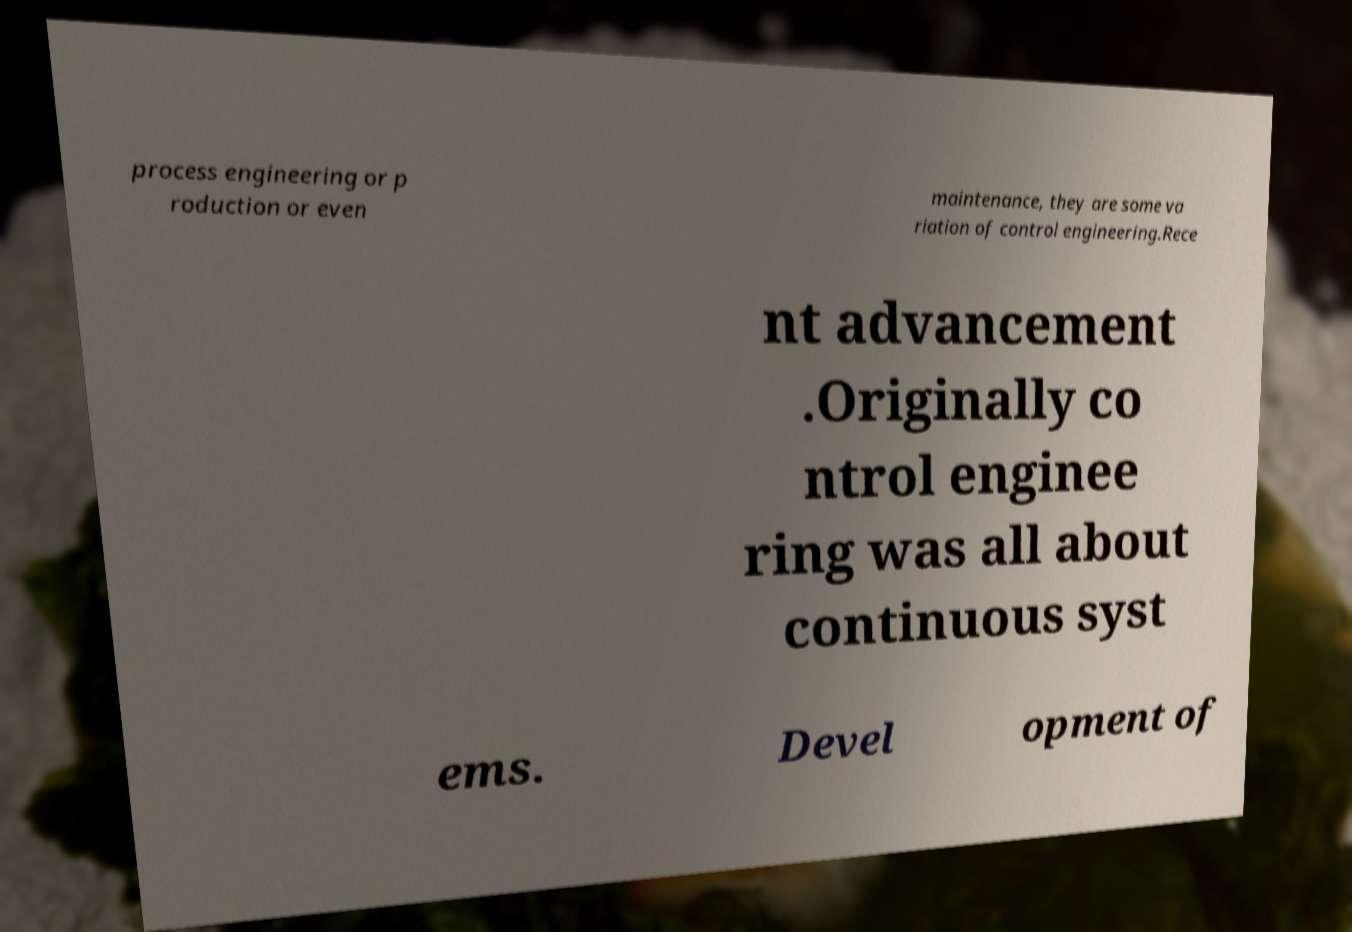Could you extract and type out the text from this image? process engineering or p roduction or even maintenance, they are some va riation of control engineering.Rece nt advancement .Originally co ntrol enginee ring was all about continuous syst ems. Devel opment of 